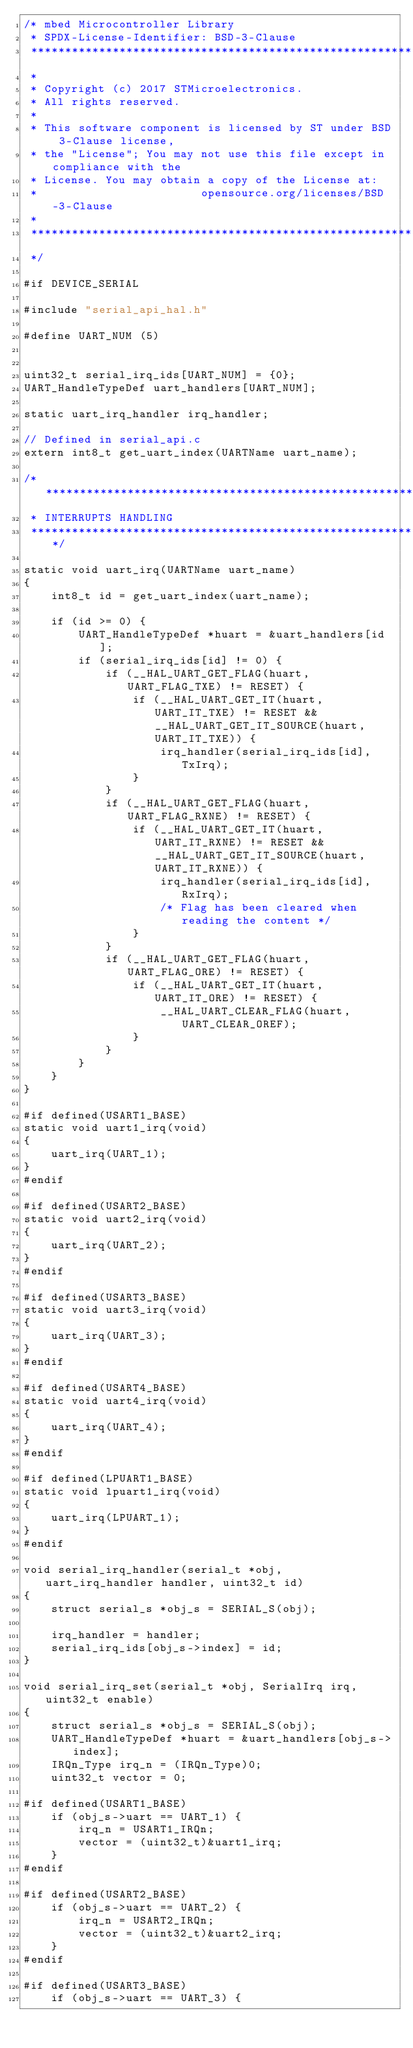<code> <loc_0><loc_0><loc_500><loc_500><_C_>/* mbed Microcontroller Library
 * SPDX-License-Identifier: BSD-3-Clause
 ******************************************************************************
 *
 * Copyright (c) 2017 STMicroelectronics.
 * All rights reserved.
 *
 * This software component is licensed by ST under BSD 3-Clause license,
 * the "License"; You may not use this file except in compliance with the
 * License. You may obtain a copy of the License at:
 *                        opensource.org/licenses/BSD-3-Clause
 *
 ******************************************************************************
 */

#if DEVICE_SERIAL

#include "serial_api_hal.h"

#define UART_NUM (5)


uint32_t serial_irq_ids[UART_NUM] = {0};
UART_HandleTypeDef uart_handlers[UART_NUM];

static uart_irq_handler irq_handler;

// Defined in serial_api.c
extern int8_t get_uart_index(UARTName uart_name);

/******************************************************************************
 * INTERRUPTS HANDLING
 ******************************************************************************/

static void uart_irq(UARTName uart_name)
{
    int8_t id = get_uart_index(uart_name);

    if (id >= 0) {
        UART_HandleTypeDef *huart = &uart_handlers[id];
        if (serial_irq_ids[id] != 0) {
            if (__HAL_UART_GET_FLAG(huart, UART_FLAG_TXE) != RESET) {
                if (__HAL_UART_GET_IT(huart, UART_IT_TXE) != RESET && __HAL_UART_GET_IT_SOURCE(huart, UART_IT_TXE)) {
                    irq_handler(serial_irq_ids[id], TxIrq);
                }
            }
            if (__HAL_UART_GET_FLAG(huart, UART_FLAG_RXNE) != RESET) {
                if (__HAL_UART_GET_IT(huart, UART_IT_RXNE) != RESET && __HAL_UART_GET_IT_SOURCE(huart, UART_IT_RXNE)) {
                    irq_handler(serial_irq_ids[id], RxIrq);
                    /* Flag has been cleared when reading the content */
                }
            }
            if (__HAL_UART_GET_FLAG(huart, UART_FLAG_ORE) != RESET) {
                if (__HAL_UART_GET_IT(huart, UART_IT_ORE) != RESET) {
                    __HAL_UART_CLEAR_FLAG(huart, UART_CLEAR_OREF);
                }
            }
        }
    }
}

#if defined(USART1_BASE)
static void uart1_irq(void)
{
    uart_irq(UART_1);
}
#endif

#if defined(USART2_BASE)
static void uart2_irq(void)
{
    uart_irq(UART_2);
}
#endif

#if defined(USART3_BASE)
static void uart3_irq(void)
{
    uart_irq(UART_3);
}
#endif

#if defined(USART4_BASE)
static void uart4_irq(void)
{
    uart_irq(UART_4);
}
#endif

#if defined(LPUART1_BASE)
static void lpuart1_irq(void)
{
    uart_irq(LPUART_1);
}
#endif

void serial_irq_handler(serial_t *obj, uart_irq_handler handler, uint32_t id)
{
    struct serial_s *obj_s = SERIAL_S(obj);

    irq_handler = handler;
    serial_irq_ids[obj_s->index] = id;
}

void serial_irq_set(serial_t *obj, SerialIrq irq, uint32_t enable)
{
    struct serial_s *obj_s = SERIAL_S(obj);
    UART_HandleTypeDef *huart = &uart_handlers[obj_s->index];
    IRQn_Type irq_n = (IRQn_Type)0;
    uint32_t vector = 0;

#if defined(USART1_BASE)
    if (obj_s->uart == UART_1) {
        irq_n = USART1_IRQn;
        vector = (uint32_t)&uart1_irq;
    }
#endif

#if defined(USART2_BASE)
    if (obj_s->uart == UART_2) {
        irq_n = USART2_IRQn;
        vector = (uint32_t)&uart2_irq;
    }
#endif

#if defined(USART3_BASE)
    if (obj_s->uart == UART_3) {</code> 